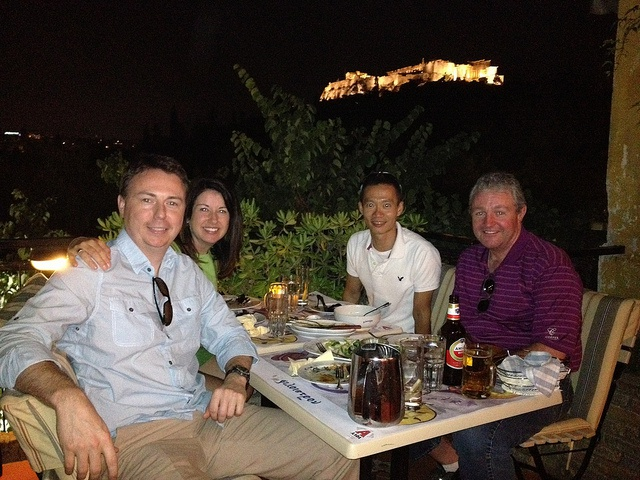Describe the objects in this image and their specific colors. I can see people in black, darkgray, lightgray, gray, and tan tones, dining table in black, darkgray, gray, and tan tones, people in black, purple, and brown tones, people in black, lightgray, darkgray, maroon, and gray tones, and potted plant in black, darkgreen, and olive tones in this image. 